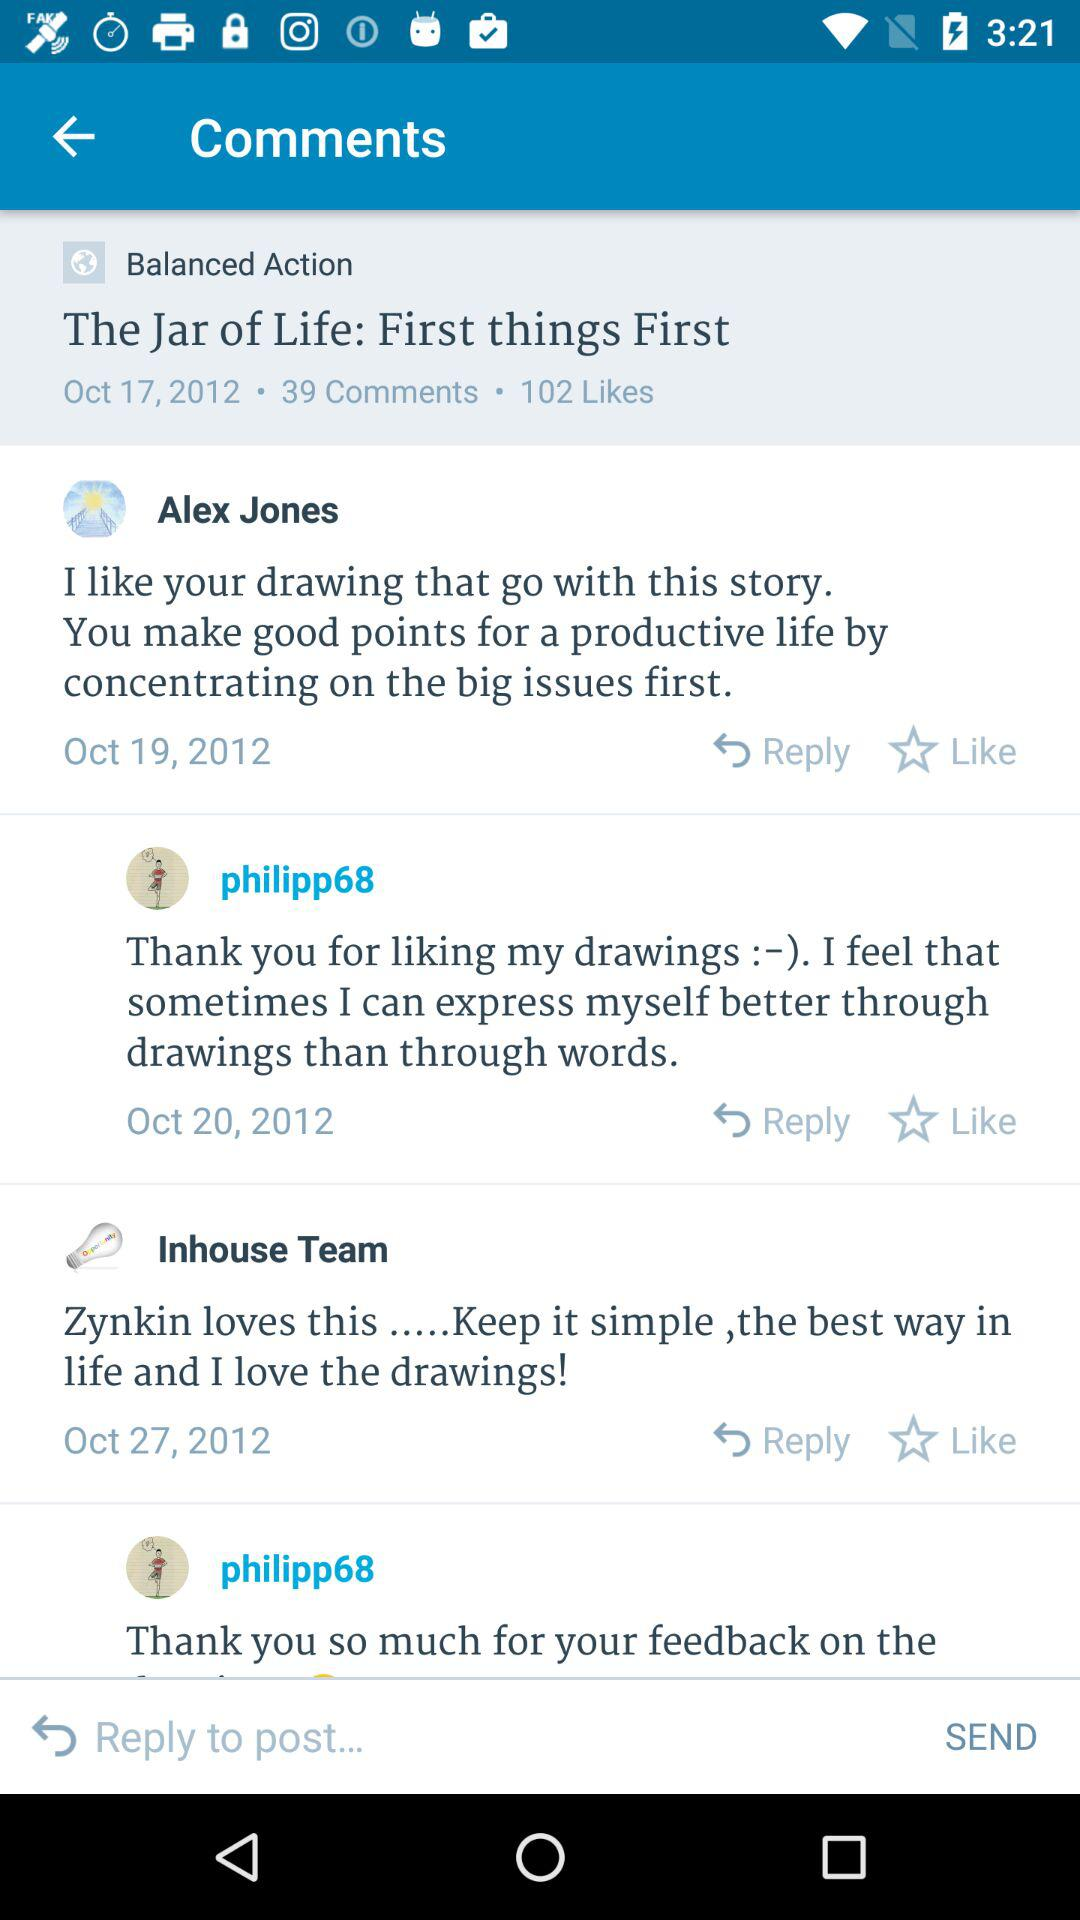Which user commented on October 20, 2012? The user who commented on October 20, 2012 is "philipp68". 